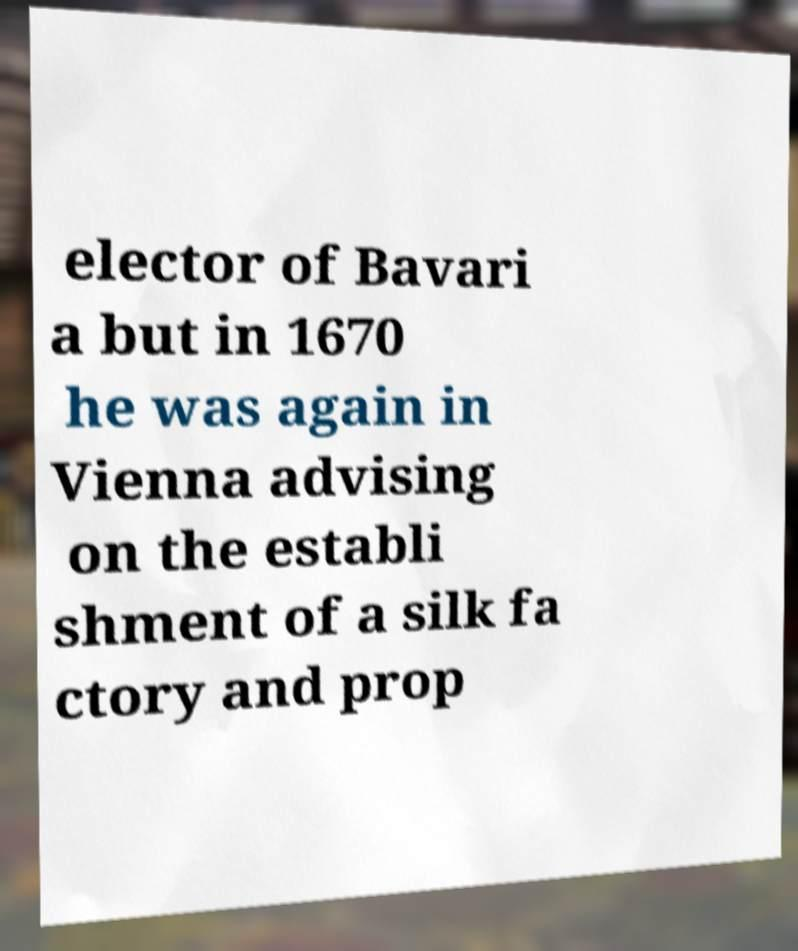There's text embedded in this image that I need extracted. Can you transcribe it verbatim? elector of Bavari a but in 1670 he was again in Vienna advising on the establi shment of a silk fa ctory and prop 